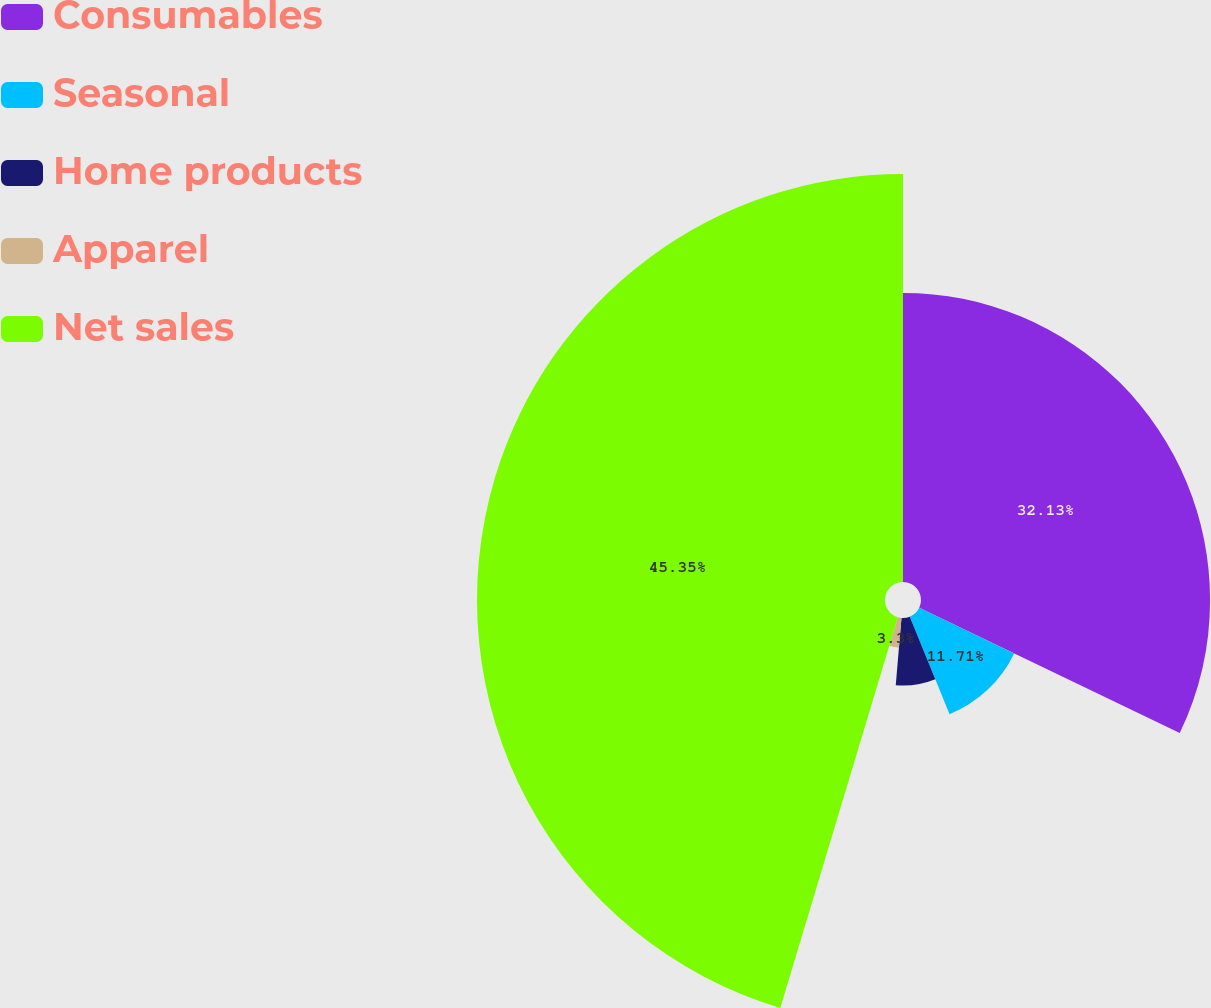Convert chart to OTSL. <chart><loc_0><loc_0><loc_500><loc_500><pie_chart><fcel>Consumables<fcel>Seasonal<fcel>Home products<fcel>Apparel<fcel>Net sales<nl><fcel>32.13%<fcel>11.71%<fcel>7.51%<fcel>3.3%<fcel>45.35%<nl></chart> 